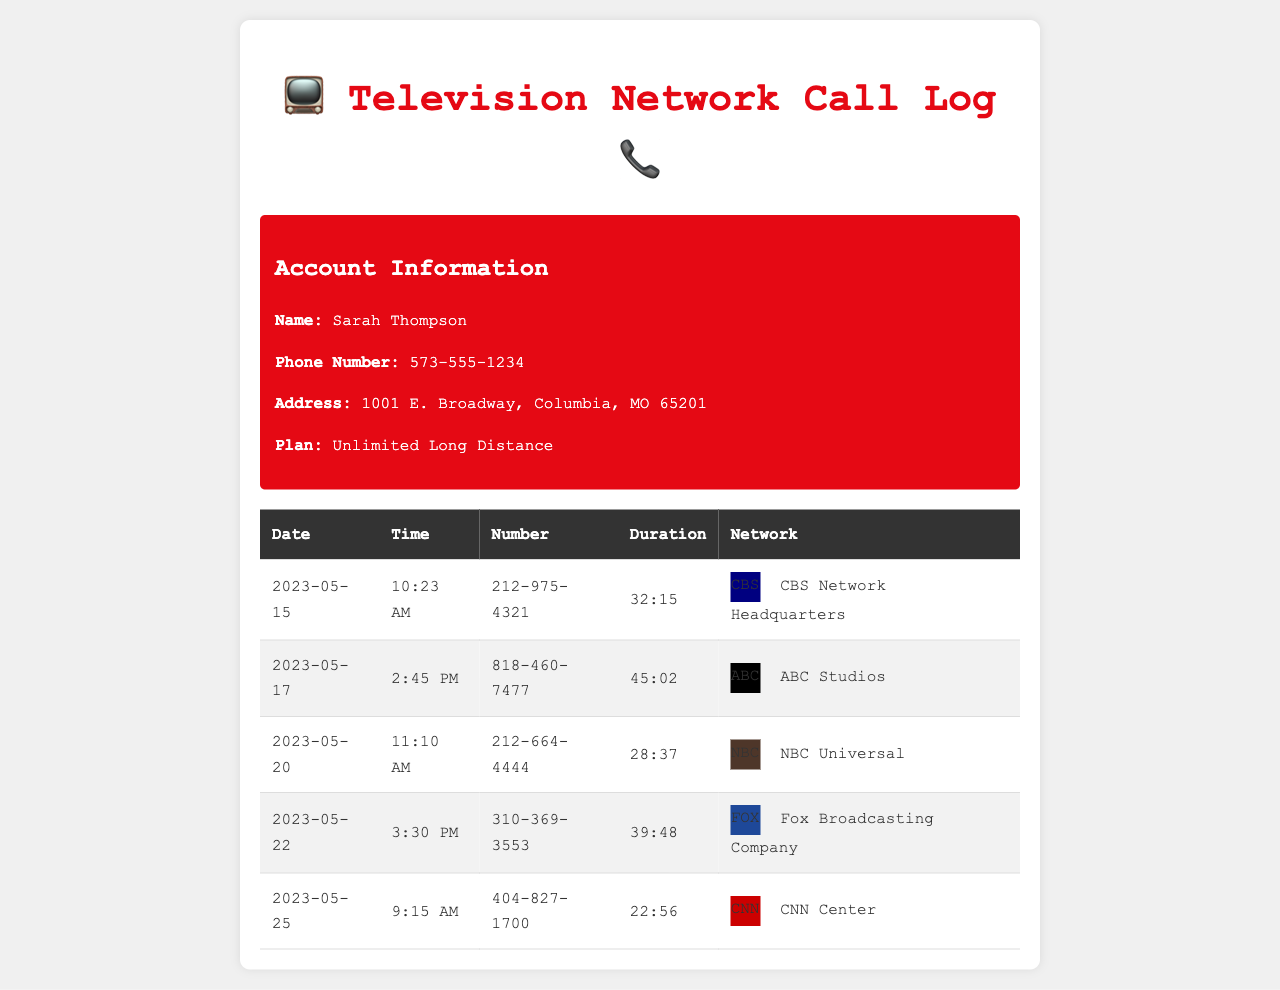What is the duration of the call to CBS Network Headquarters? The duration of the call to CBS Network Headquarters on May 15, 2023, is 32 minutes and 15 seconds.
Answer: 32:15 Who is the account holder? The account holder's name is provided in the account information section at the top of the document.
Answer: Sarah Thompson Which network was called on May 20, 2023? The call on May 20, 2023, was made to NBC Universal, based on the details in the log.
Answer: NBC Universal What time was the call to ABC Studios? The call to ABC Studios on May 17, 2023, occurred at 2:45 PM, as recorded in the call log.
Answer: 2:45 PM How many seconds did the call to FOX Broadcasting Company last? The duration of the call to FOX Broadcasting Company is converted from the listed format to seconds for this calculation (39 minutes and 48 seconds = 2388 seconds).
Answer: 2388 seconds Which call had the longest duration? The longest duration is deduced from comparing all call durations listed the log.
Answer: 45:02 What is the area code for the call made to CNN Center? The area code for CNN Center on May 25, 2023, is taken from the phone number listed in the call log.
Answer: 404 How many calls were made in total? The total number of calls can be counted from the entries provided in the table.
Answer: 5 What was the date of the call to NBC Universal? The date of the call to NBC Universal is specified in the log, presenting the information clearly.
Answer: 2023-05-20 Which city is the account holder located in? The city is found in the address section of the account information provided in the document.
Answer: Columbia 